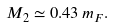Convert formula to latex. <formula><loc_0><loc_0><loc_500><loc_500>M _ { 2 } \simeq 0 . 4 3 \, m _ { F } .</formula> 